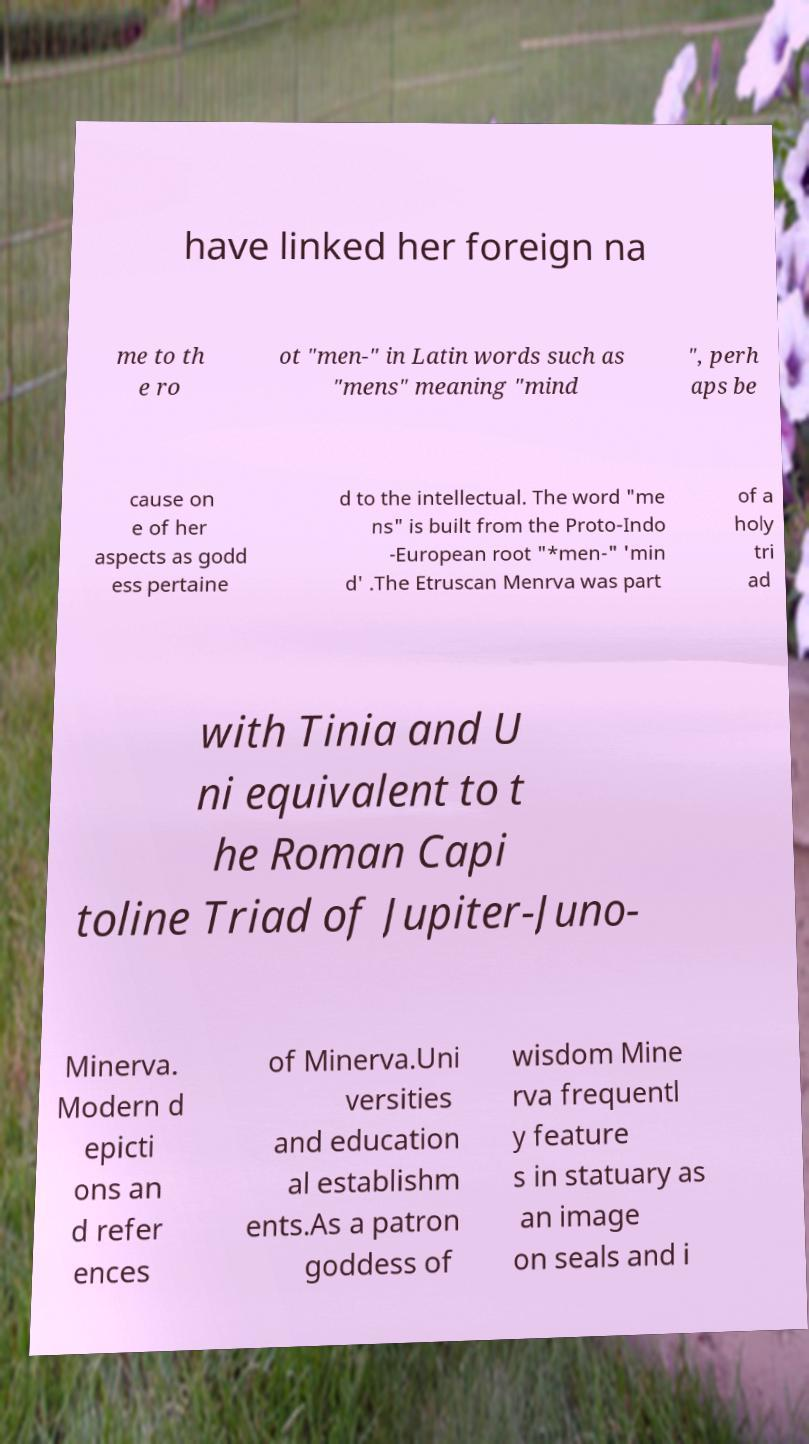Could you assist in decoding the text presented in this image and type it out clearly? have linked her foreign na me to th e ro ot "men-" in Latin words such as "mens" meaning "mind ", perh aps be cause on e of her aspects as godd ess pertaine d to the intellectual. The word "me ns" is built from the Proto-Indo -European root "*men-" 'min d' .The Etruscan Menrva was part of a holy tri ad with Tinia and U ni equivalent to t he Roman Capi toline Triad of Jupiter-Juno- Minerva. Modern d epicti ons an d refer ences of Minerva.Uni versities and education al establishm ents.As a patron goddess of wisdom Mine rva frequentl y feature s in statuary as an image on seals and i 